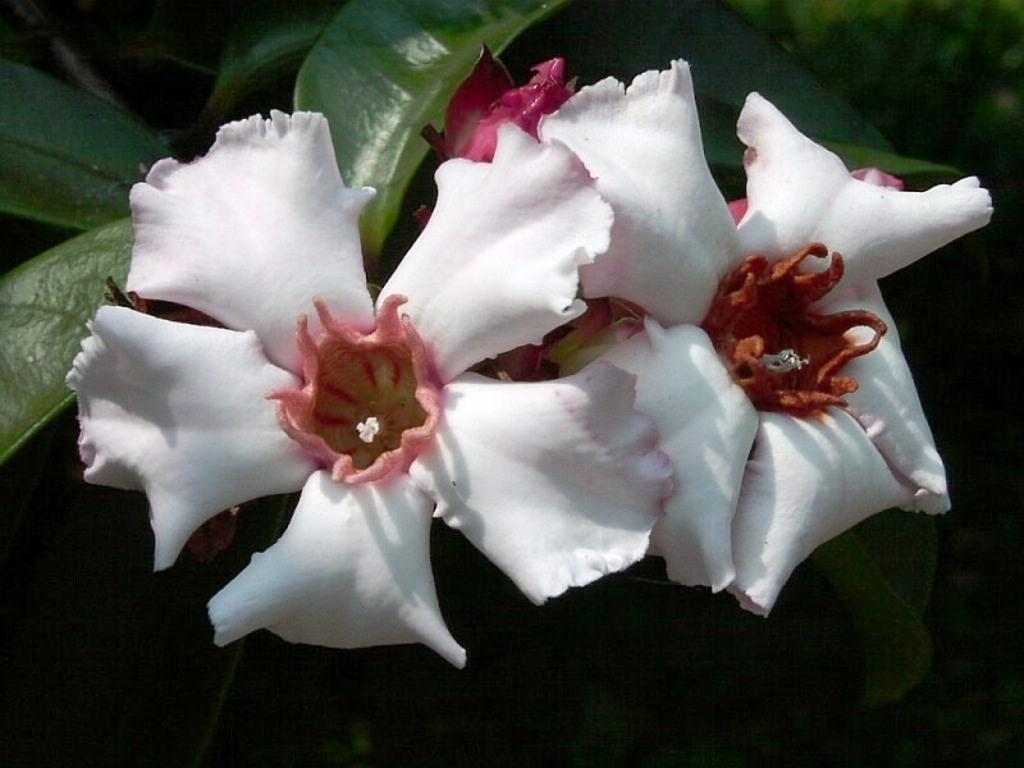How many flowers can be seen in the image? There are two flowers in the image. What else can be found on the plant with the flowers? There are leaves on the plant in the image. Can you tell me how many eyes are visible on the flowers in the image? There are no eyes visible on the flowers in the image, as flowers do not have eyes. 